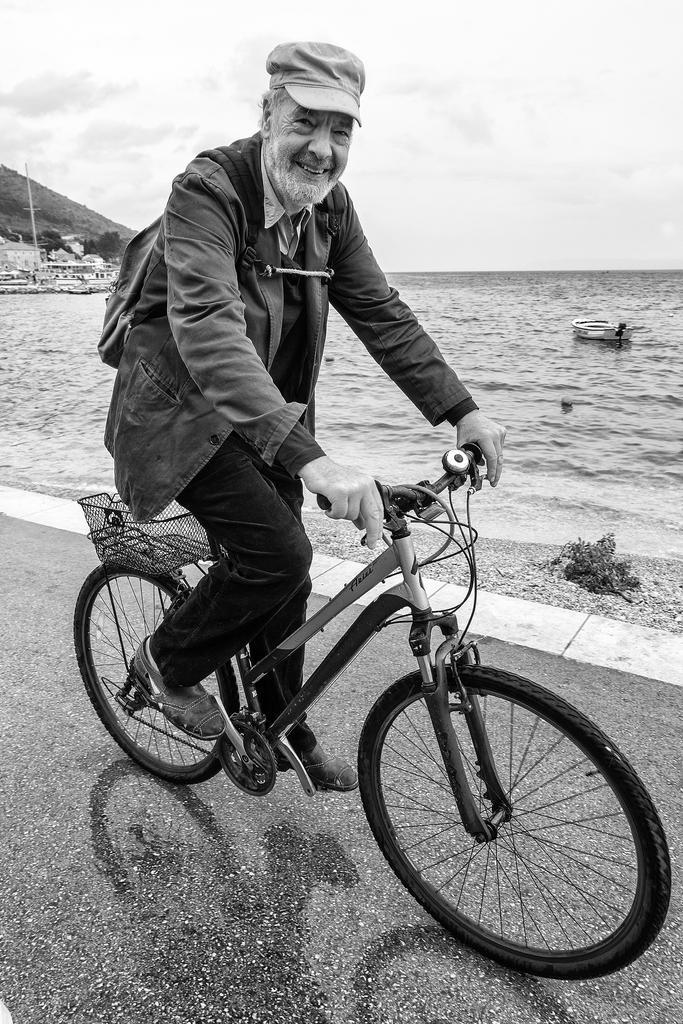Can you describe this image briefly? In the middle of the image a man is riding bicycle on the road and smiling. At the top of the image there are some clouds. Top left side of the image there is a hill. Right side of the image there is a boat on the water. 